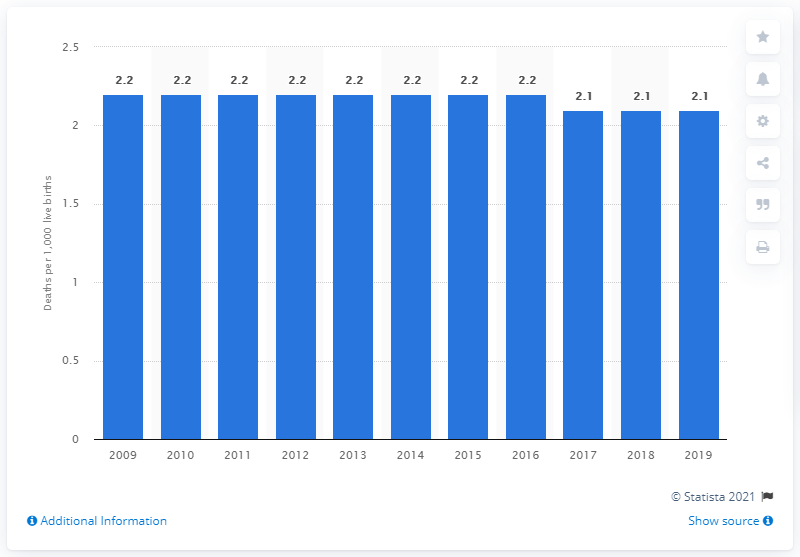Indicate a few pertinent items in this graphic. In 2019, the infant mortality rate in Singapore was 2.1 per 1,000 live births. 